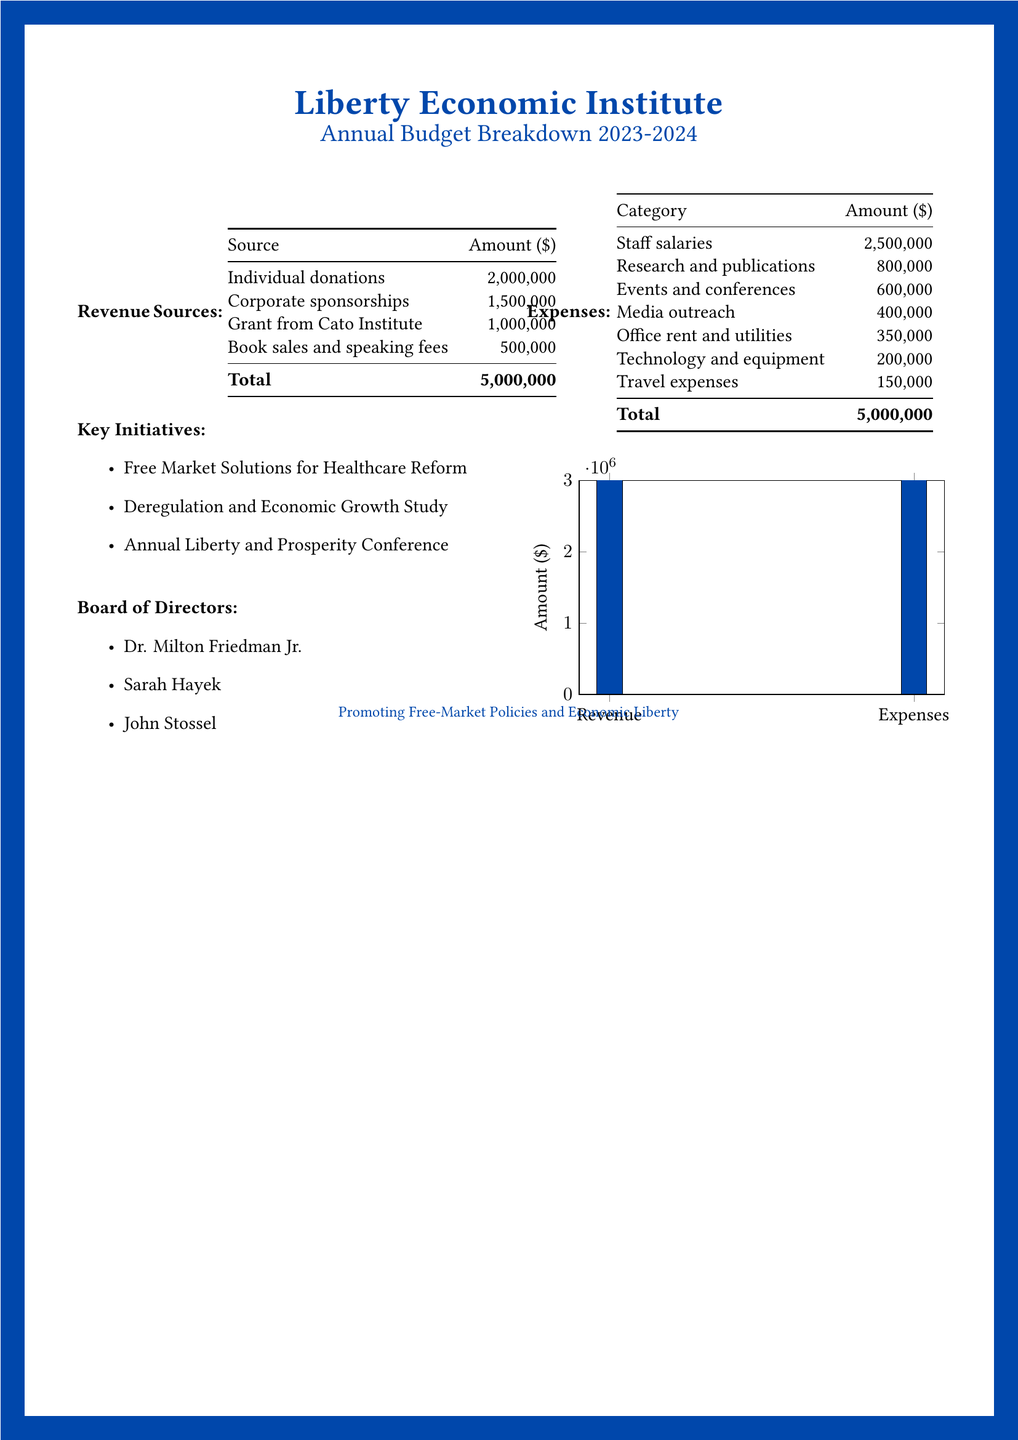What is the total revenue? The total revenue is the sum of all revenue sources in the document, which is 2,000,000 + 1,500,000 + 1,000,000 + 500,000 = 5,000,000.
Answer: 5,000,000 What are the sources of revenue? The sources of revenue listed in the document include individual donations, corporate sponsorships, a grant from the Cato Institute, and book sales and speaking fees.
Answer: Individual donations, corporate sponsorships, grant from Cato Institute, book sales and speaking fees How much is allocated for staff salaries? The document specifies the amount allocated for staff salaries as 2,500,000.
Answer: 2,500,000 Which initiative focuses on healthcare reform? One of the key initiatives aimed at healthcare is named Free Market Solutions for Healthcare Reform.
Answer: Free Market Solutions for Healthcare Reform Who is a member of the Board of Directors? The document lists members of the Board of Directors, one of which is Dr. Milton Friedman Jr.
Answer: Dr. Milton Friedman Jr What is the amount for research and publications? The amount designated for research and publications in the document is specified as 800,000.
Answer: 800,000 How much is spent on media outreach? The expense for media outreach as mentioned in the document is 400,000.
Answer: 400,000 What is the total amount for the budget? The total amount for the budget is equal for both revenue and expenses, noted as 5,000,000 each in the document.
Answer: 5,000,000 